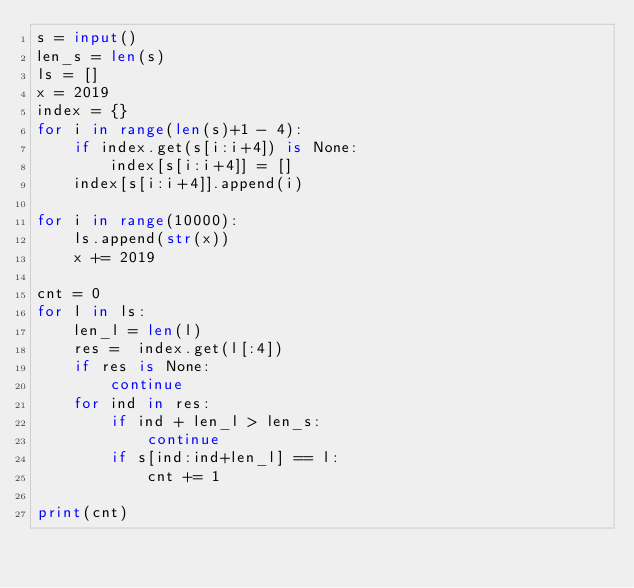Convert code to text. <code><loc_0><loc_0><loc_500><loc_500><_Python_>s = input()
len_s = len(s)
ls = []
x = 2019
index = {}
for i in range(len(s)+1 - 4):
    if index.get(s[i:i+4]) is None:
        index[s[i:i+4]] = []
    index[s[i:i+4]].append(i)

for i in range(10000):
    ls.append(str(x))
    x += 2019

cnt = 0
for l in ls:
    len_l = len(l)
    res =  index.get(l[:4])
    if res is None:
        continue
    for ind in res:
        if ind + len_l > len_s:
            continue
        if s[ind:ind+len_l] == l:
            cnt += 1

print(cnt)</code> 